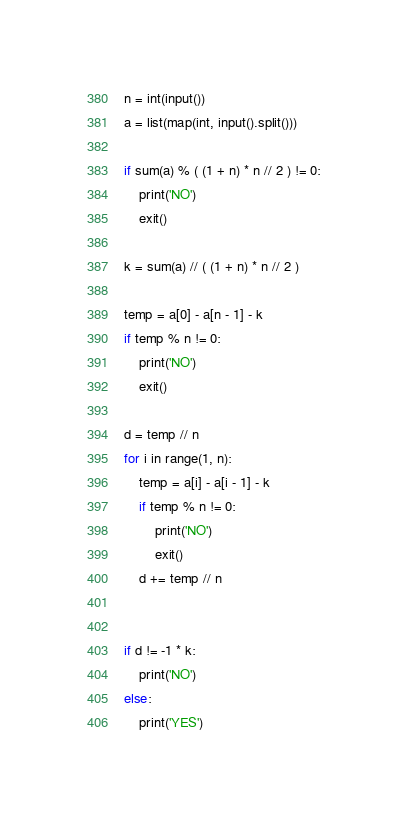<code> <loc_0><loc_0><loc_500><loc_500><_Python_>n = int(input())
a = list(map(int, input().split()))

if sum(a) % ( (1 + n) * n // 2 ) != 0:
    print('NO')
    exit()

k = sum(a) // ( (1 + n) * n // 2 )

temp = a[0] - a[n - 1] - k
if temp % n != 0:
    print('NO')
    exit()

d = temp // n
for i in range(1, n):
    temp = a[i] - a[i - 1] - k
    if temp % n != 0:
        print('NO')
        exit()
    d += temp // n


if d != -1 * k:
    print('NO')
else:
    print('YES')
</code> 